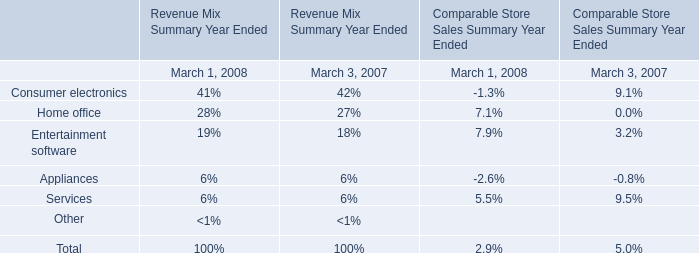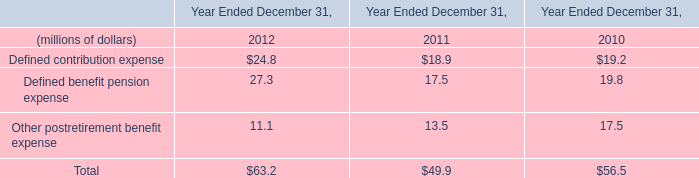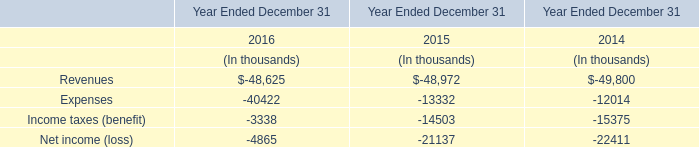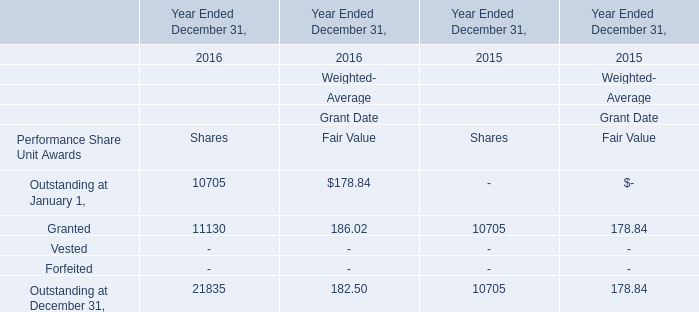As As the chart 3 shows,what is the Weighted-Average Grant Date Fair Value for Granted in 2016 Ended December 31? 
Answer: 186.02. 